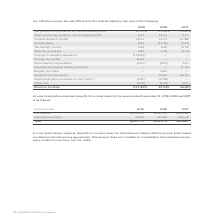According to Adtran's financial document, What does Income (loss) before expense (benefit) for income taxes for international entities reflect? income (loss) based on statutory transfer pricing agreements.. The document states: "r income taxes for international entities reflects income (loss) based on statutory transfer pricing agreements. This amount does not correlate to con..." Also, What was the total income(loss) in 2017? According to the financial document, $44,687 (in thousands). The relevant text states: "Total $(24,777) $(33,371) $44,687..." Also, What was the income for U.S. entities in 2019? According to the financial document, $(29,829) (in thousands). The relevant text states: "U.S. entities $(29,829) $(74,131) $26,552..." Also, can you calculate: What was the percentage change for total income between 2018 and 2019? To answer this question, I need to perform calculations using the financial data. The calculation is: (-$24,777-(-$33,371))/-$33,371, which equals -25.75 (percentage). This is based on the information: "Total $(24,777) $(33,371) $44,687 Total $(24,777) $(33,371) $44,687..." The key data points involved are: 24,777, 33,371. Also, can you calculate: What was the change in income from International entities between 2018 and 2019? Based on the calculation: 5,052-40,760, the result is -35708 (in thousands). This is based on the information: "International entities 5,052 40,760 18,135 International entities 5,052 40,760 18,135..." The key data points involved are: 40,760, 5,052. Also, can you calculate: What was the change in income from U.S. entities between 2018 and 2019? Based on the calculation: -$29,829-(-$74,131), the result is 44302 (in thousands). This is based on the information: "U.S. entities $(29,829) $(74,131) $26,552 U.S. entities $(29,829) $(74,131) $26,552..." The key data points involved are: 29,829, 74,131. 